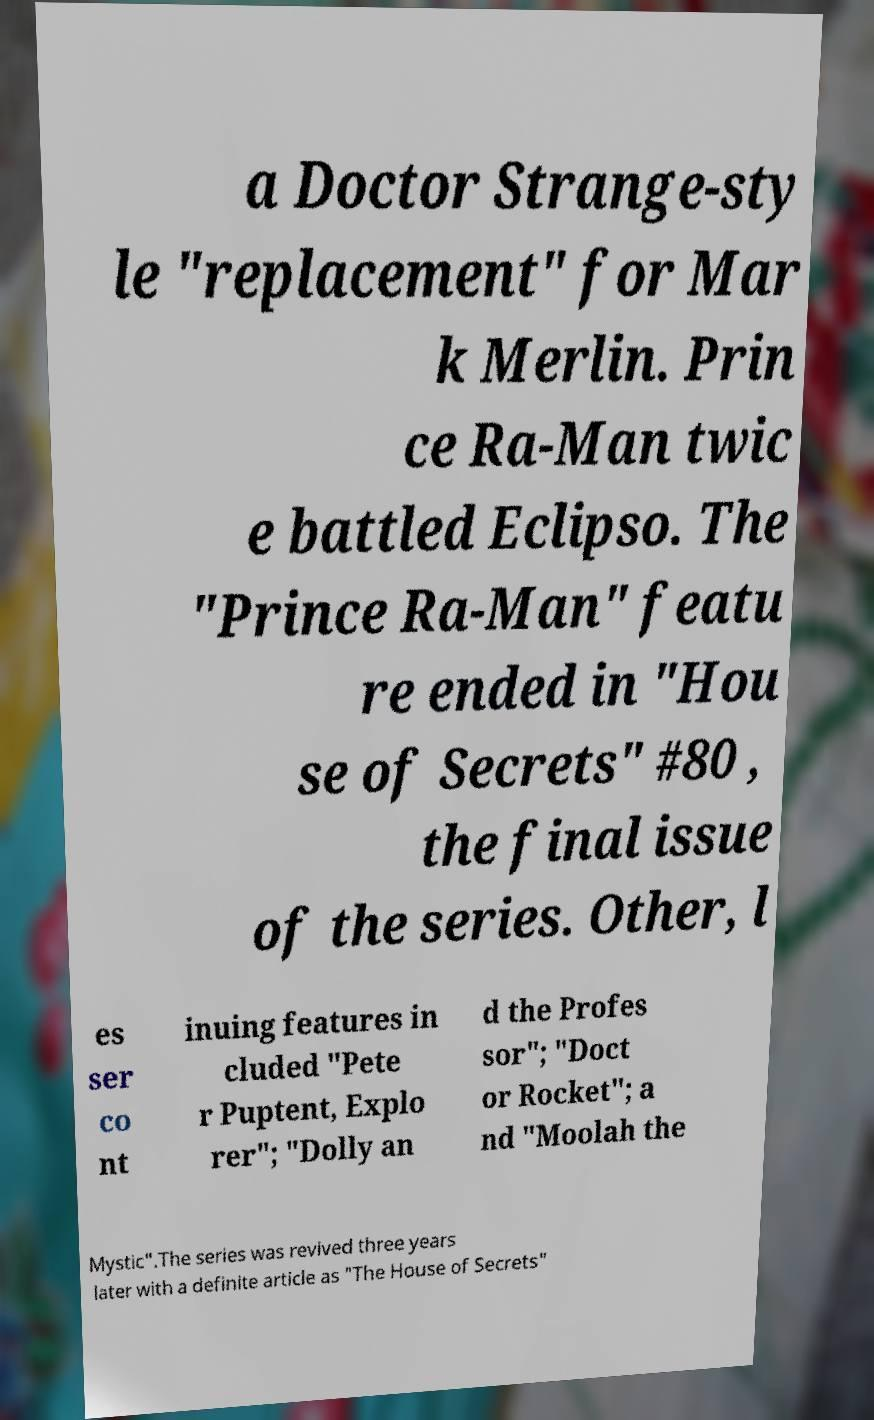Can you accurately transcribe the text from the provided image for me? a Doctor Strange-sty le "replacement" for Mar k Merlin. Prin ce Ra-Man twic e battled Eclipso. The "Prince Ra-Man" featu re ended in "Hou se of Secrets" #80 , the final issue of the series. Other, l es ser co nt inuing features in cluded "Pete r Puptent, Explo rer"; "Dolly an d the Profes sor"; "Doct or Rocket"; a nd "Moolah the Mystic".The series was revived three years later with a definite article as "The House of Secrets" 